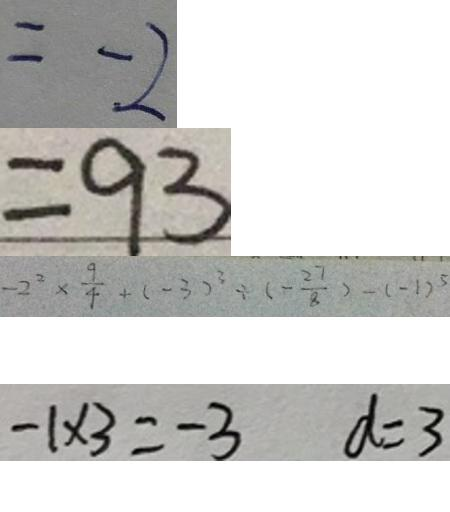<formula> <loc_0><loc_0><loc_500><loc_500>= - 2 
 = 9 3 
 - 2 ^ { 2 } \times \frac { 9 } { 4 } + ( - 3 ) ^ { 2 } \div ( - \frac { 2 7 } { 8 } ) - ( - 1 ) ^ { 5 } 
 - 1 \times 3 = - 3 d = 3</formula> 